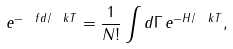Convert formula to latex. <formula><loc_0><loc_0><loc_500><loc_500>e ^ { - \ f d / \ k T } = \frac { 1 } { N ! } \int d \Gamma \, e ^ { - H / \ k T } ,</formula> 